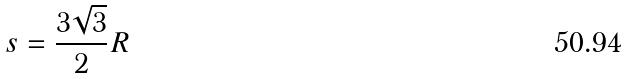Convert formula to latex. <formula><loc_0><loc_0><loc_500><loc_500>s = \frac { 3 \sqrt { 3 } } { 2 } R</formula> 